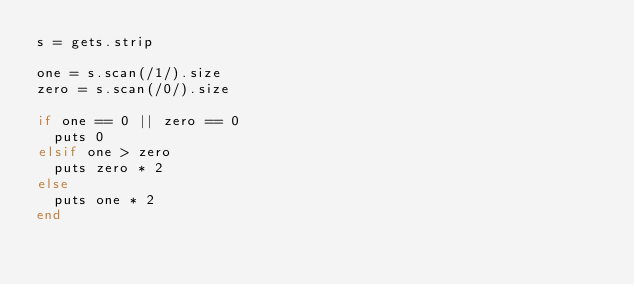Convert code to text. <code><loc_0><loc_0><loc_500><loc_500><_Ruby_>s = gets.strip

one = s.scan(/1/).size
zero = s.scan(/0/).size

if one == 0 || zero == 0
  puts 0
elsif one > zero
  puts zero * 2
else
  puts one * 2
end
</code> 